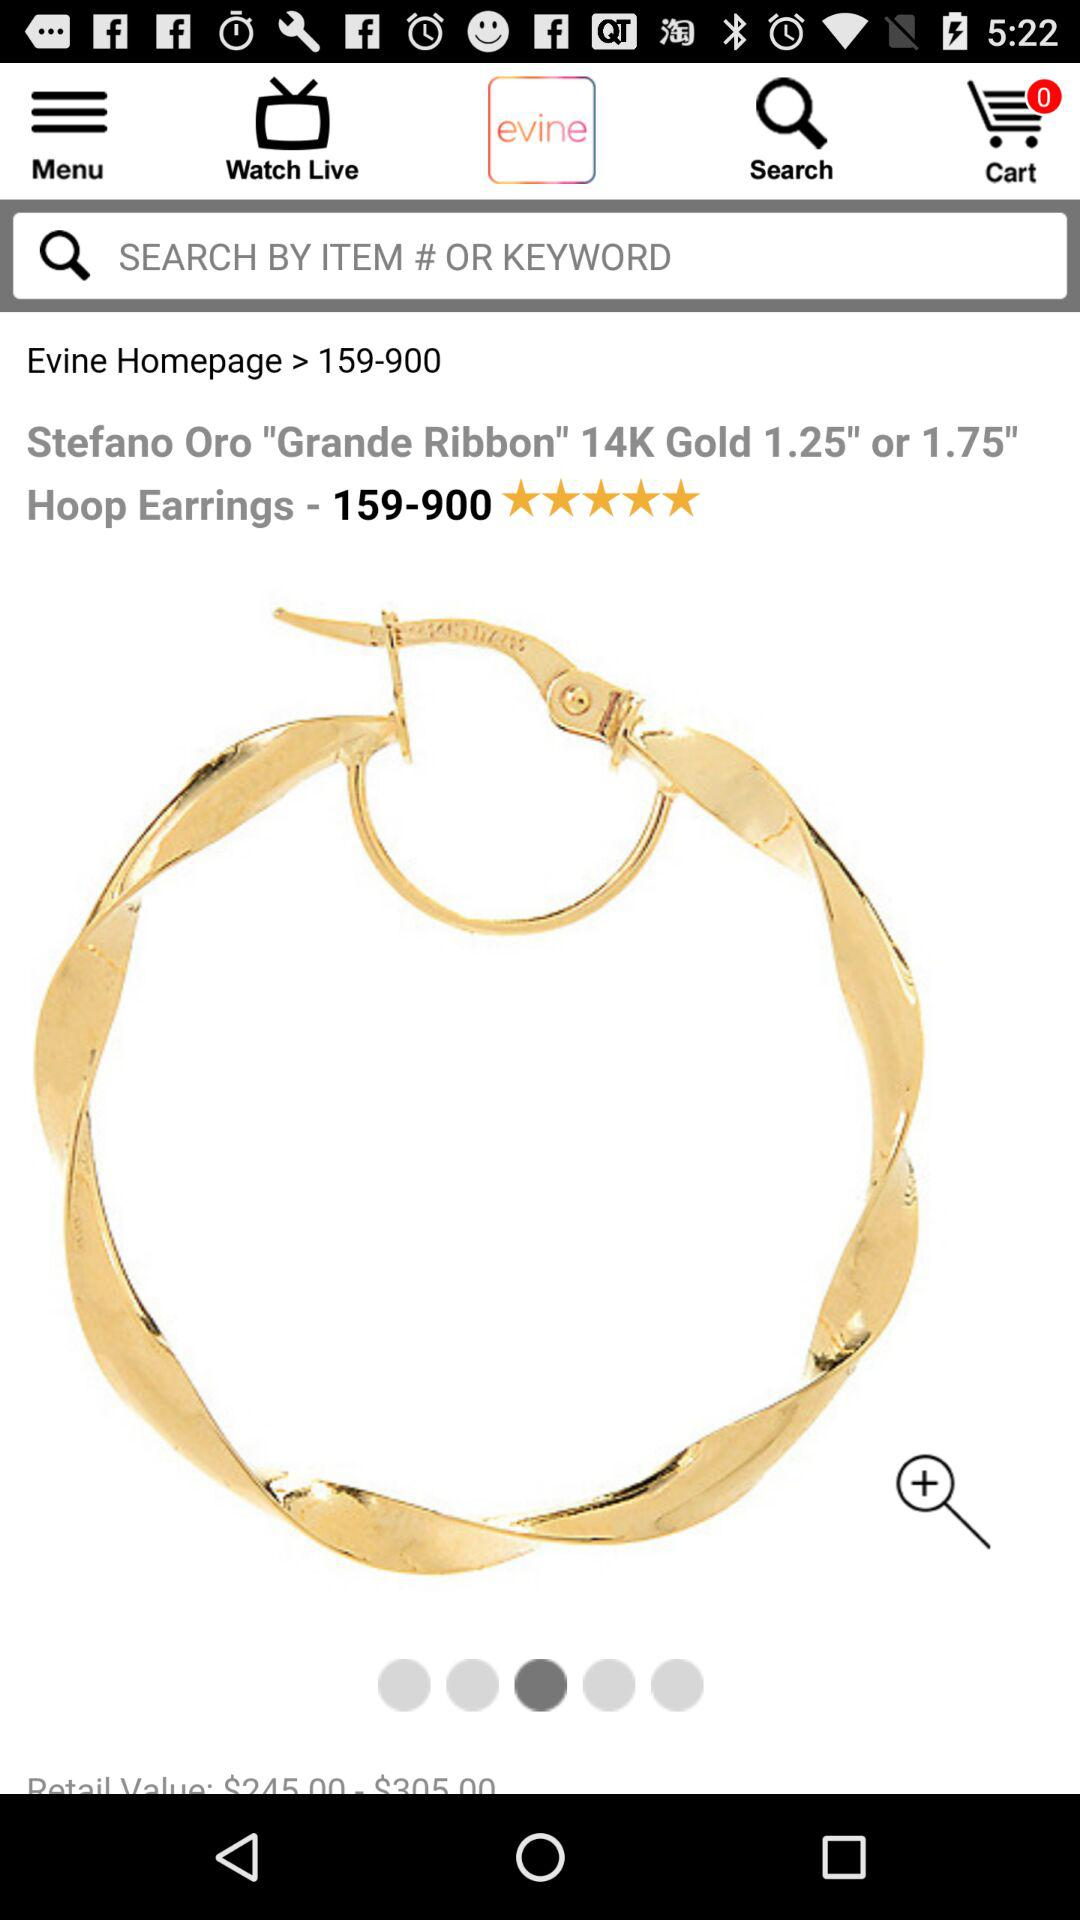What is the rating of hoop earrings? The rating is 5 stars. 